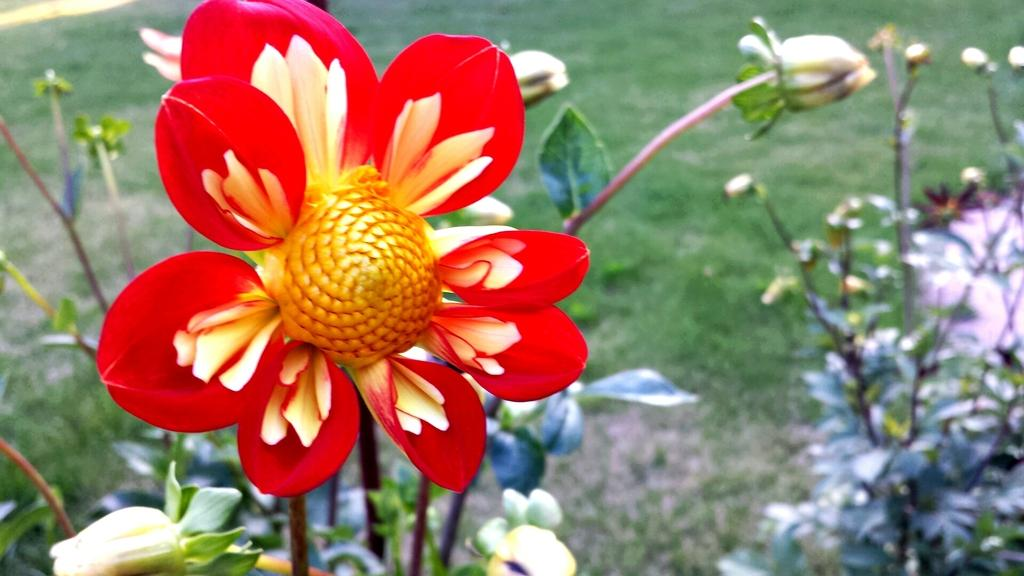What type of vegetation can be seen in the image? There are flowers, plants, and grass visible in the image. Can you describe the plants in the image? The plants in the image are not specified, but they are present along with the flowers and grass. What is the natural environment depicted in the image? The natural environment in the image includes flowers, plants, and grass. How many sticks can be seen in the image? There are no sticks present in the image; it features flowers, plants, and grass. What type of trip is being taken in the image? There is no trip depicted in the image; it is a still image of flowers, plants, and grass. 